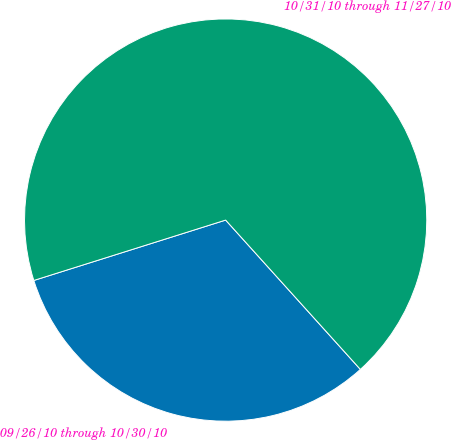Convert chart. <chart><loc_0><loc_0><loc_500><loc_500><pie_chart><fcel>09/26/10 through 10/30/10<fcel>10/31/10 through 11/27/10<nl><fcel>31.83%<fcel>68.17%<nl></chart> 